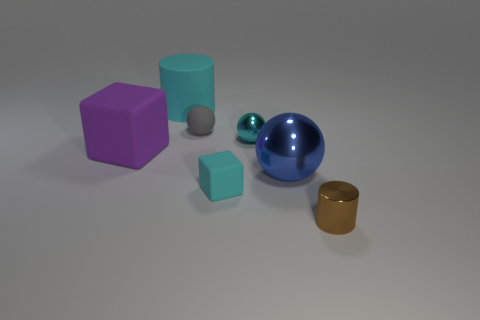There is a small shiny ball; is its color the same as the tiny matte object in front of the cyan metallic sphere?
Provide a short and direct response. Yes. How many other objects are the same size as the brown metal thing?
Make the answer very short. 3. What is the shape of the tiny metallic thing behind the rubber block in front of the blue metal object that is right of the gray ball?
Provide a short and direct response. Sphere. Do the brown cylinder and the gray rubber thing that is behind the big blue shiny object have the same size?
Offer a very short reply. Yes. What is the color of the big object that is to the right of the purple object and behind the big blue ball?
Keep it short and to the point. Cyan. How many other objects are the same shape as the blue metallic object?
Offer a very short reply. 2. Is the color of the large matte object that is behind the tiny metal sphere the same as the tiny sphere to the right of the tiny rubber cube?
Make the answer very short. Yes. Is the size of the cylinder on the right side of the big cyan cylinder the same as the block that is in front of the blue object?
Your response must be concise. Yes. There is a sphere in front of the purple block that is to the left of the cylinder that is to the left of the tiny brown cylinder; what is it made of?
Ensure brevity in your answer.  Metal. Is the small gray object the same shape as the large cyan matte thing?
Ensure brevity in your answer.  No. 